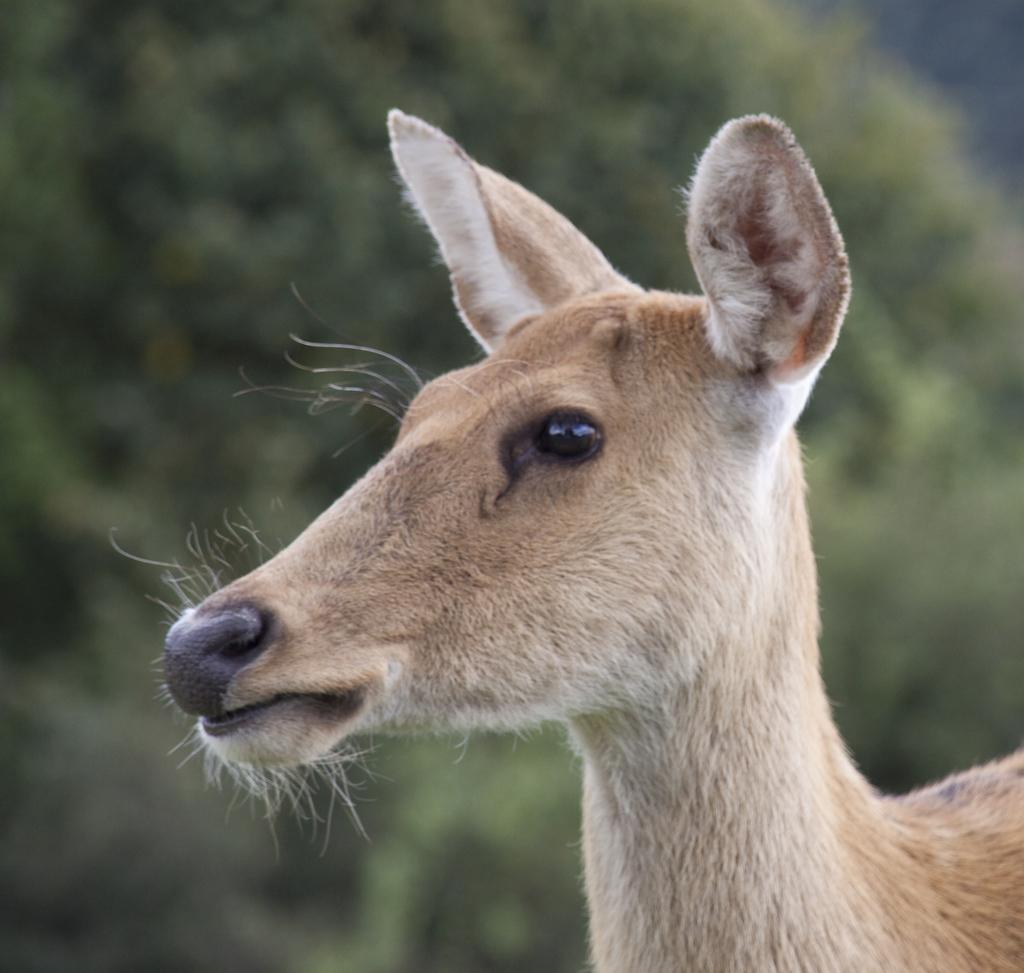How would you summarize this image in a sentence or two? In this picture, we can see a deer. Behind the deer, there is a blurred background. 